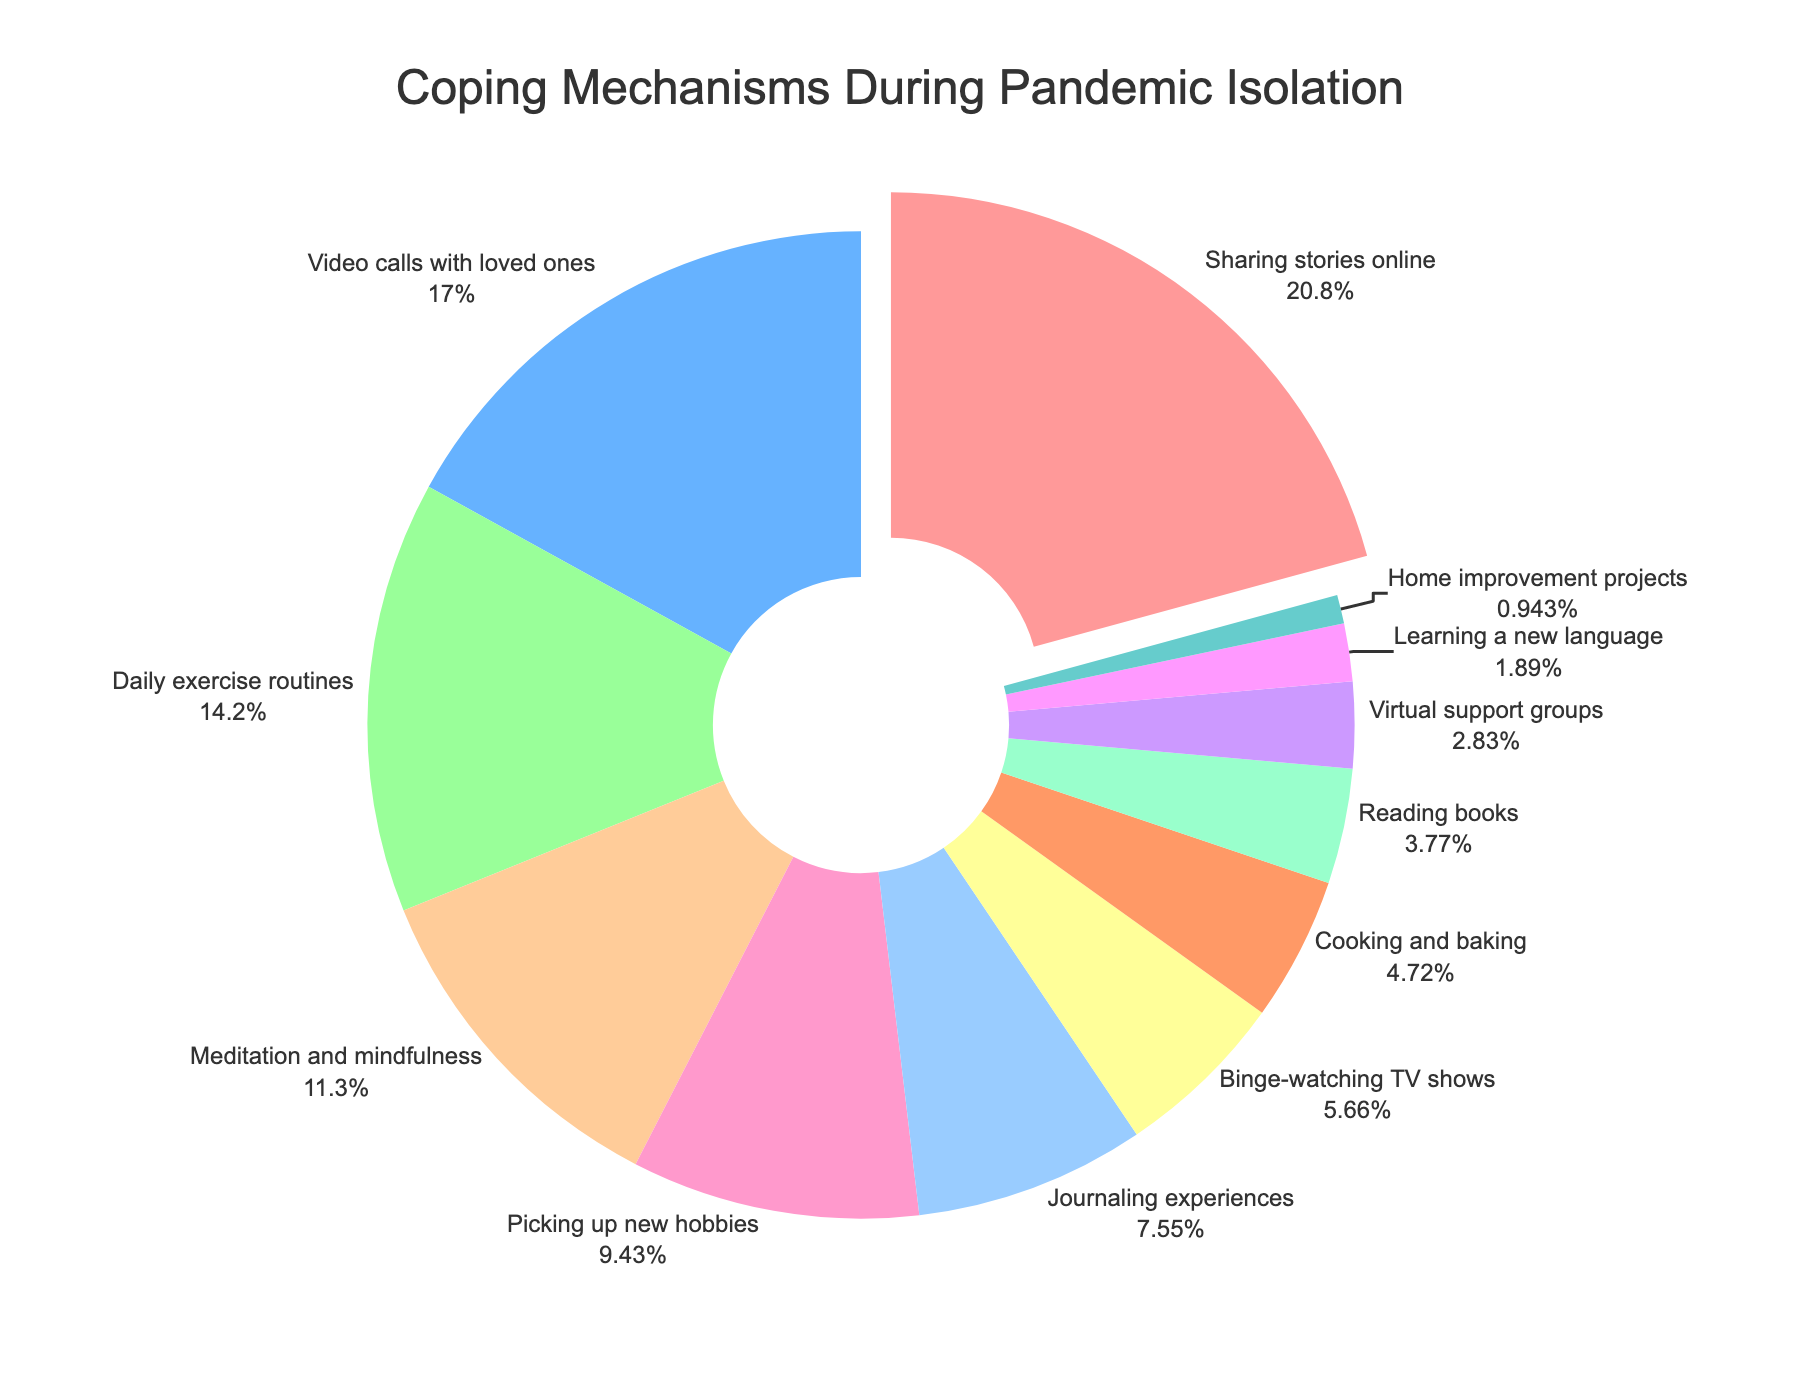What coping mechanism was most commonly used during pandemic isolation? Looking at the pie chart, the largest slice of the pie represents 'Sharing stories online' with 22%. This indicates it was the most commonly used coping mechanism.
Answer: Sharing stories online How much more popular was 'Video calls with loved ones' than 'Journaling experiences'? 'Video calls with loved ones' make up 18% of the pie, whereas 'Journaling experiences' account for 8%. The difference is 18% - 8% = 10%.
Answer: 10% Which coping mechanisms make up more than 10% of the distribution each? The pie chart shows that 'Sharing stories online' (22%), 'Video calls with loved ones' (18%), 'Daily exercise routines' (15%), and 'Meditation and mindfulness' (12%) each constitute more than 10%.
Answer: Sharing stories online, Video calls with loved ones, Daily exercise routines, Meditation and mindfulness What is the combined percentage of people who used 'Cooking and baking' and 'Reading books' as their coping mechanism? 'Cooking and baking' accounts for 5% and 'Reading books' constitutes 4%. Combined, they make up 5% + 4% = 9%.
Answer: 9% Among 'Binge-watching TV shows', 'Cooking and baking', and 'Reading books', which one was the least used coping mechanism? According to the pie chart, 'Reading books' occupies 4%, while 'Binge-watching TV shows' and 'Cooking and baking' account for 6% and 5%, respectively. Therefore, 'Reading books' is the least used among them.
Answer: Reading books How many coping mechanisms were used by less than 5% of people each? From the pie chart, 'Virtual support groups' (3%), 'Learning a new language' (2%), and 'Home improvement projects' (1%) each have less than 5%. There are 3 coping mechanisms in total.
Answer: 3 Which color represents 'Sharing stories online,' and what percentage does it cover? In the pie chart, 'Sharing stories online' is represented by the largest slice and is colored red. It covers 22%.
Answer: Red, 22% What is the total percentage of people engaging in 'Daily exercise routines' and 'Meditation and mindfulness'? 'Daily exercise routines' account for 15%, and 'Meditation and mindfulness' account for 12%. Together, they make up 15% + 12% = 27%.
Answer: 27% What segment of the population used 'Picking up new hobbies' as a coping mechanism, and how does its percentage compare to 'Video calls with loved ones'? 'Picking up new hobbies' occupies 10% of the pie, whereas 'Video calls with loved ones' make up 18%. Therefore, 'Video calls with loved ones' is 18% - 10% = 8% more popular.
Answer: 8% What coping mechanisms make up the smallest portion of the distribution, and what percentage do they cover combined? 'Home improvement projects' account for 1%, the smallest portion of the distribution.
Answer: 1% 